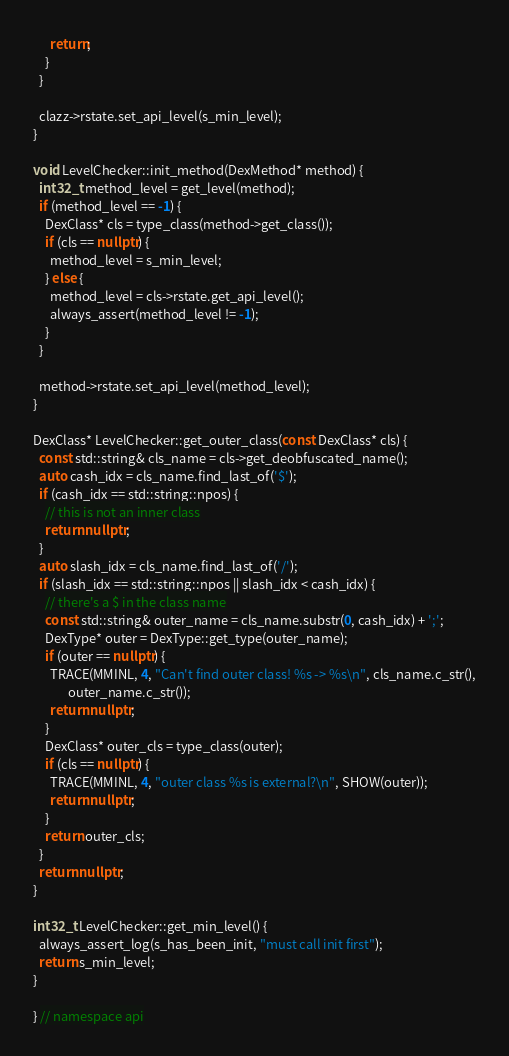<code> <loc_0><loc_0><loc_500><loc_500><_C++_>      return;
    }
  }

  clazz->rstate.set_api_level(s_min_level);
}

void LevelChecker::init_method(DexMethod* method) {
  int32_t method_level = get_level(method);
  if (method_level == -1) {
    DexClass* cls = type_class(method->get_class());
    if (cls == nullptr) {
      method_level = s_min_level;
    } else {
      method_level = cls->rstate.get_api_level();
      always_assert(method_level != -1);
    }
  }

  method->rstate.set_api_level(method_level);
}

DexClass* LevelChecker::get_outer_class(const DexClass* cls) {
  const std::string& cls_name = cls->get_deobfuscated_name();
  auto cash_idx = cls_name.find_last_of('$');
  if (cash_idx == std::string::npos) {
    // this is not an inner class
    return nullptr;
  }
  auto slash_idx = cls_name.find_last_of('/');
  if (slash_idx == std::string::npos || slash_idx < cash_idx) {
    // there's a $ in the class name
    const std::string& outer_name = cls_name.substr(0, cash_idx) + ';';
    DexType* outer = DexType::get_type(outer_name);
    if (outer == nullptr) {
      TRACE(MMINL, 4, "Can't find outer class! %s -> %s\n", cls_name.c_str(),
            outer_name.c_str());
      return nullptr;
    }
    DexClass* outer_cls = type_class(outer);
    if (cls == nullptr) {
      TRACE(MMINL, 4, "outer class %s is external?\n", SHOW(outer));
      return nullptr;
    }
    return outer_cls;
  }
  return nullptr;
}

int32_t LevelChecker::get_min_level() {
  always_assert_log(s_has_been_init, "must call init first");
  return s_min_level;
}

} // namespace api
</code> 